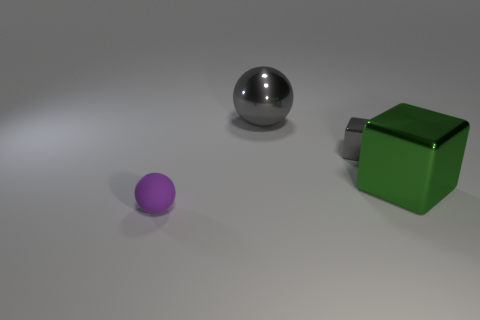Add 3 small balls. How many objects exist? 7 Subtract 2 cubes. How many cubes are left? 0 Subtract all green spheres. Subtract all green cubes. How many spheres are left? 2 Subtract all large blue cylinders. Subtract all tiny balls. How many objects are left? 3 Add 3 tiny gray shiny cubes. How many tiny gray shiny cubes are left? 4 Add 4 small yellow matte blocks. How many small yellow matte blocks exist? 4 Subtract all purple balls. How many balls are left? 1 Subtract 1 gray cubes. How many objects are left? 3 